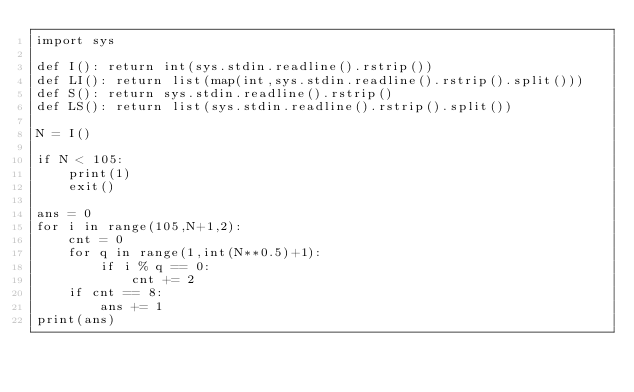<code> <loc_0><loc_0><loc_500><loc_500><_Python_>import sys

def I(): return int(sys.stdin.readline().rstrip())
def LI(): return list(map(int,sys.stdin.readline().rstrip().split()))
def S(): return sys.stdin.readline().rstrip()
def LS(): return list(sys.stdin.readline().rstrip().split())

N = I()

if N < 105:
    print(1)
    exit()

ans = 0
for i in range(105,N+1,2):
    cnt = 0
    for q in range(1,int(N**0.5)+1):
        if i % q == 0:
            cnt += 2
    if cnt == 8:
        ans += 1
print(ans)

</code> 